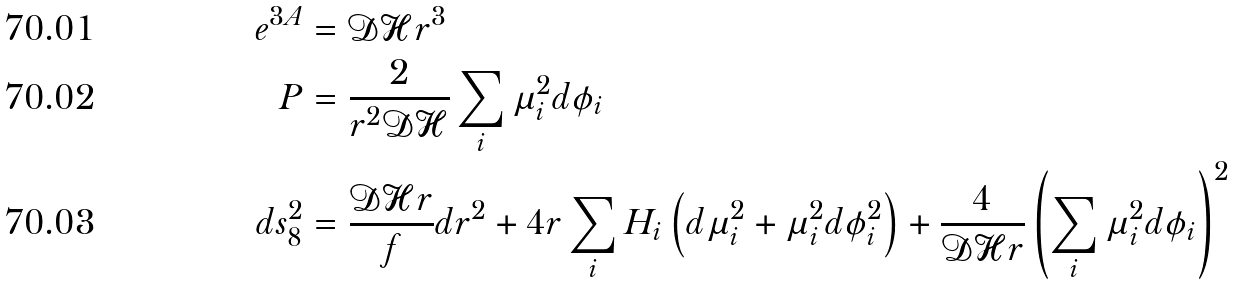<formula> <loc_0><loc_0><loc_500><loc_500>e ^ { 3 A } & = \mathcal { D H } r ^ { 3 } \\ P & = \frac { 2 } { r ^ { 2 } \mathcal { D H } } \sum _ { i } \mu ^ { 2 } _ { i } d \phi _ { i } \\ d s ^ { 2 } _ { 8 } & = \frac { \mathcal { D H } r } { f } d r ^ { 2 } + 4 r \sum _ { i } H _ { i } \left ( d \mu _ { i } ^ { 2 } + \mu _ { i } ^ { 2 } d \phi _ { i } ^ { 2 } \right ) + \frac { 4 } { \mathcal { D H } r } \left ( \sum _ { i } \mu ^ { 2 } _ { i } d \phi _ { i } \right ) ^ { 2 }</formula> 